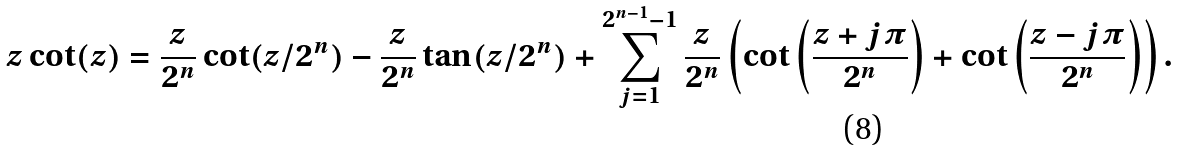<formula> <loc_0><loc_0><loc_500><loc_500>z \cot ( z ) = \frac { z } { 2 ^ { n } } \cot ( z / 2 ^ { n } ) - \frac { z } { 2 ^ { n } } \tan ( z / 2 ^ { n } ) + \sum _ { j = 1 } ^ { 2 ^ { n - 1 } - 1 } \frac { z } { 2 ^ { n } } \left ( \cot \left ( \frac { z + j \pi } { 2 ^ { n } } \right ) + \cot \left ( \frac { z - j \pi } { 2 ^ { n } } \right ) \right ) .</formula> 